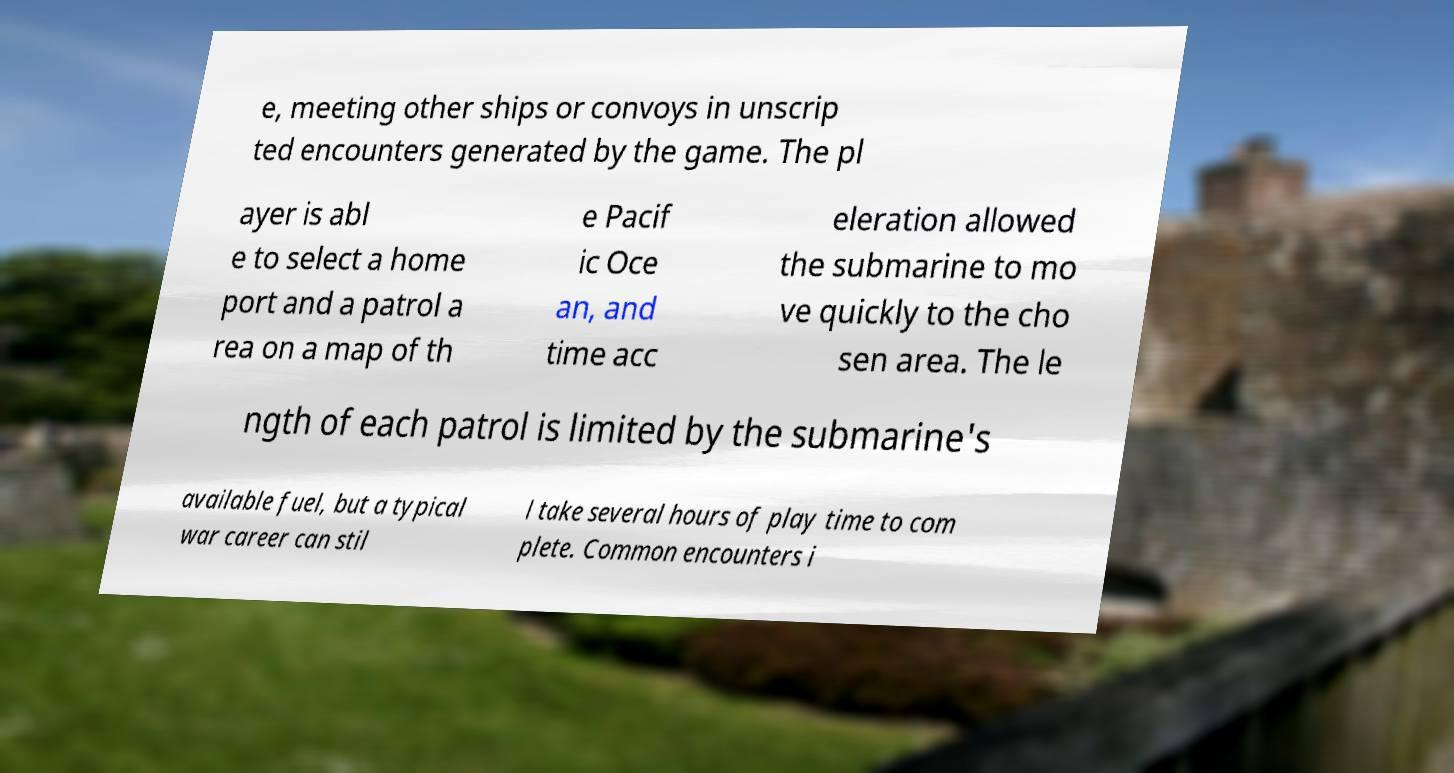What messages or text are displayed in this image? I need them in a readable, typed format. e, meeting other ships or convoys in unscrip ted encounters generated by the game. The pl ayer is abl e to select a home port and a patrol a rea on a map of th e Pacif ic Oce an, and time acc eleration allowed the submarine to mo ve quickly to the cho sen area. The le ngth of each patrol is limited by the submarine's available fuel, but a typical war career can stil l take several hours of play time to com plete. Common encounters i 